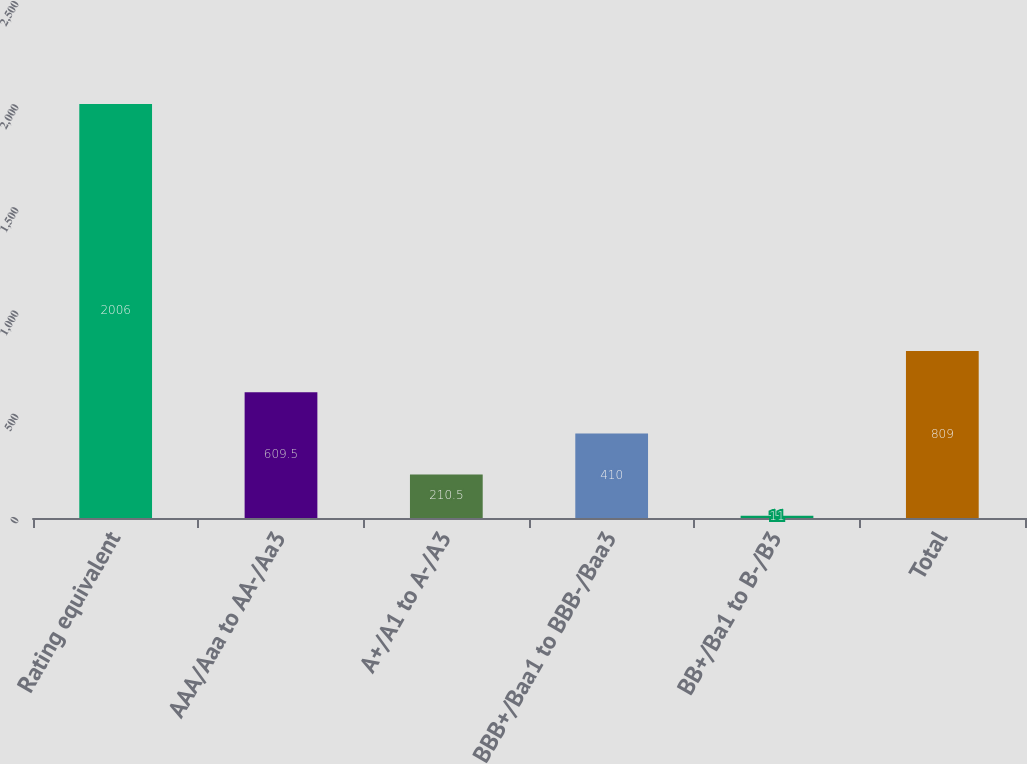Convert chart to OTSL. <chart><loc_0><loc_0><loc_500><loc_500><bar_chart><fcel>Rating equivalent<fcel>AAA/Aaa to AA-/Aa3<fcel>A+/A1 to A-/A3<fcel>BBB+/Baa1 to BBB-/Baa3<fcel>BB+/Ba1 to B-/B3<fcel>Total<nl><fcel>2006<fcel>609.5<fcel>210.5<fcel>410<fcel>11<fcel>809<nl></chart> 